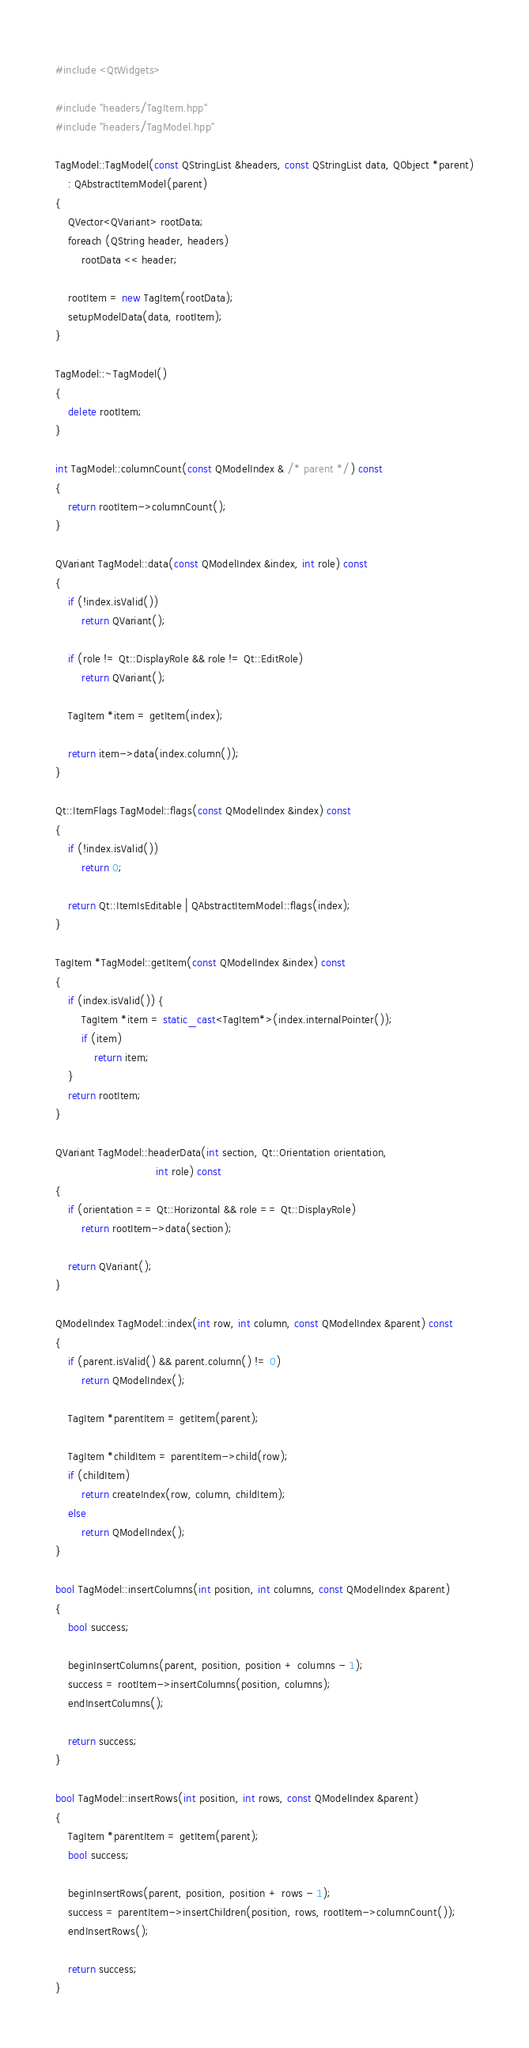<code> <loc_0><loc_0><loc_500><loc_500><_C++_>
#include <QtWidgets>

#include "headers/TagItem.hpp"
#include "headers/TagModel.hpp"

TagModel::TagModel(const QStringList &headers, const QStringList data, QObject *parent)
    : QAbstractItemModel(parent)
{
    QVector<QVariant> rootData;
    foreach (QString header, headers)
        rootData << header;

    rootItem = new TagItem(rootData);
    setupModelData(data, rootItem);
}

TagModel::~TagModel()
{
    delete rootItem;
}

int TagModel::columnCount(const QModelIndex & /* parent */) const
{
    return rootItem->columnCount();
}

QVariant TagModel::data(const QModelIndex &index, int role) const
{
    if (!index.isValid())
        return QVariant();

    if (role != Qt::DisplayRole && role != Qt::EditRole)
        return QVariant();

    TagItem *item = getItem(index);

    return item->data(index.column());
}

Qt::ItemFlags TagModel::flags(const QModelIndex &index) const
{
    if (!index.isValid())
        return 0;

    return Qt::ItemIsEditable | QAbstractItemModel::flags(index);
}

TagItem *TagModel::getItem(const QModelIndex &index) const
{
    if (index.isValid()) {
        TagItem *item = static_cast<TagItem*>(index.internalPointer());
        if (item)
            return item;
    }
    return rootItem;
}

QVariant TagModel::headerData(int section, Qt::Orientation orientation,
                               int role) const
{
    if (orientation == Qt::Horizontal && role == Qt::DisplayRole)
        return rootItem->data(section);

    return QVariant();
}

QModelIndex TagModel::index(int row, int column, const QModelIndex &parent) const
{
    if (parent.isValid() && parent.column() != 0)
        return QModelIndex();

    TagItem *parentItem = getItem(parent);

    TagItem *childItem = parentItem->child(row);
    if (childItem)
        return createIndex(row, column, childItem);
    else
        return QModelIndex();
}

bool TagModel::insertColumns(int position, int columns, const QModelIndex &parent)
{
    bool success;

    beginInsertColumns(parent, position, position + columns - 1);
    success = rootItem->insertColumns(position, columns);
    endInsertColumns();

    return success;
}

bool TagModel::insertRows(int position, int rows, const QModelIndex &parent)
{
    TagItem *parentItem = getItem(parent);
    bool success;

    beginInsertRows(parent, position, position + rows - 1);
    success = parentItem->insertChildren(position, rows, rootItem->columnCount());
    endInsertRows();

    return success;
}
</code> 